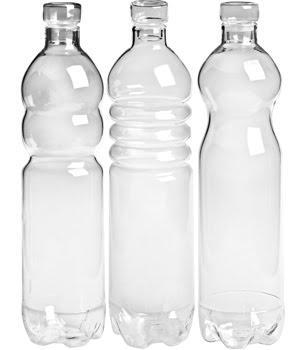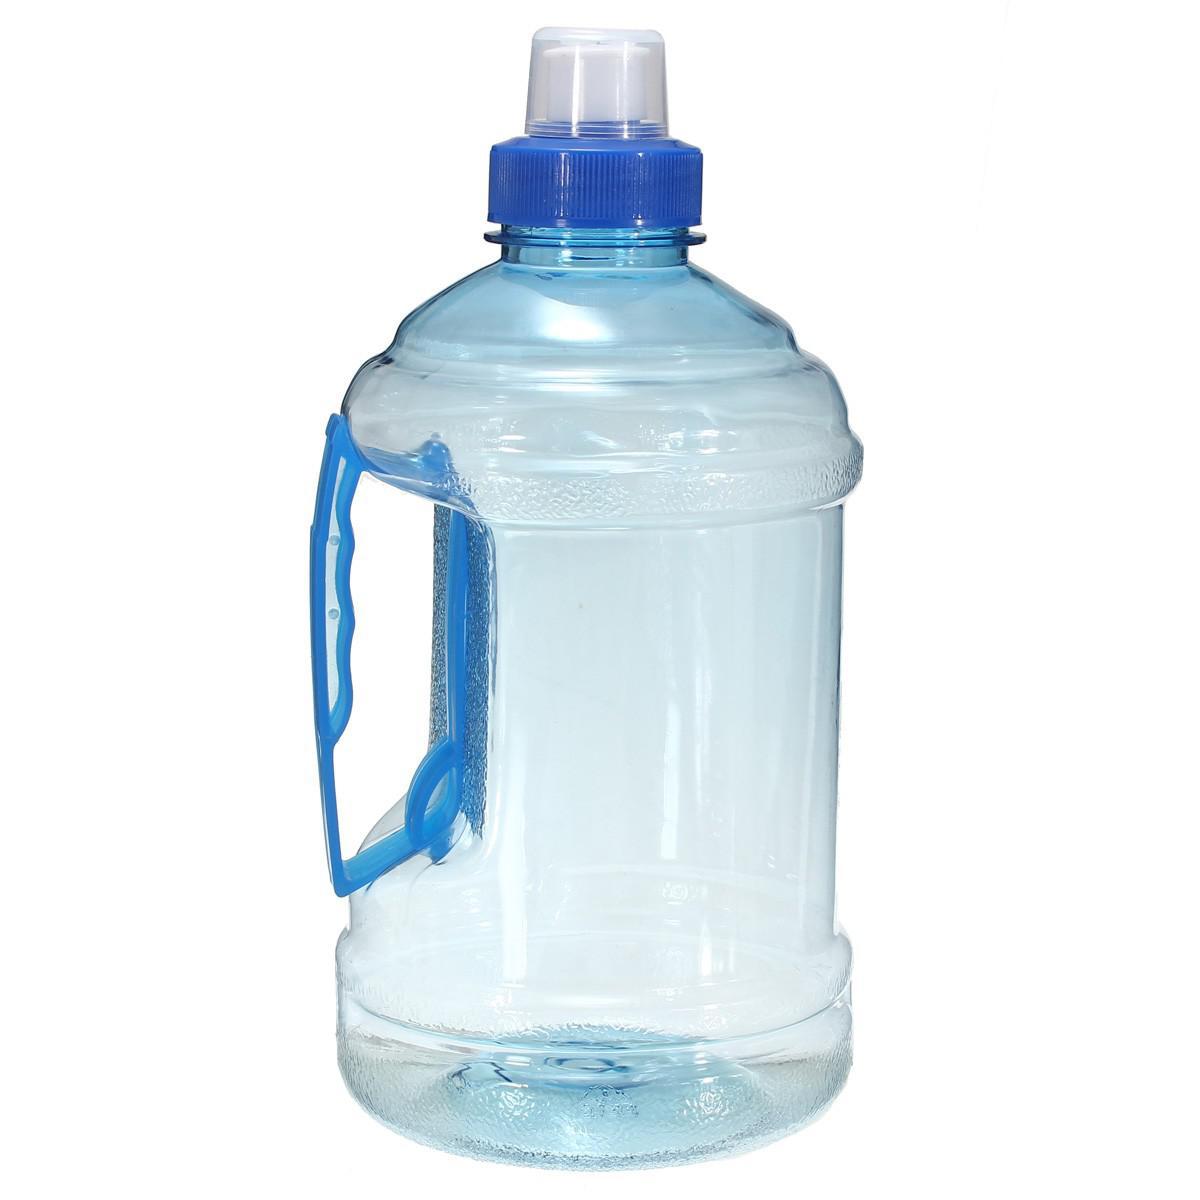The first image is the image on the left, the second image is the image on the right. Analyze the images presented: Is the assertion "An image includes a clear water bottle with exactly three ribbed bands around its upper midsection." valid? Answer yes or no. Yes. The first image is the image on the left, the second image is the image on the right. Assess this claim about the two images: "There are more than three bottles.". Correct or not? Answer yes or no. Yes. 